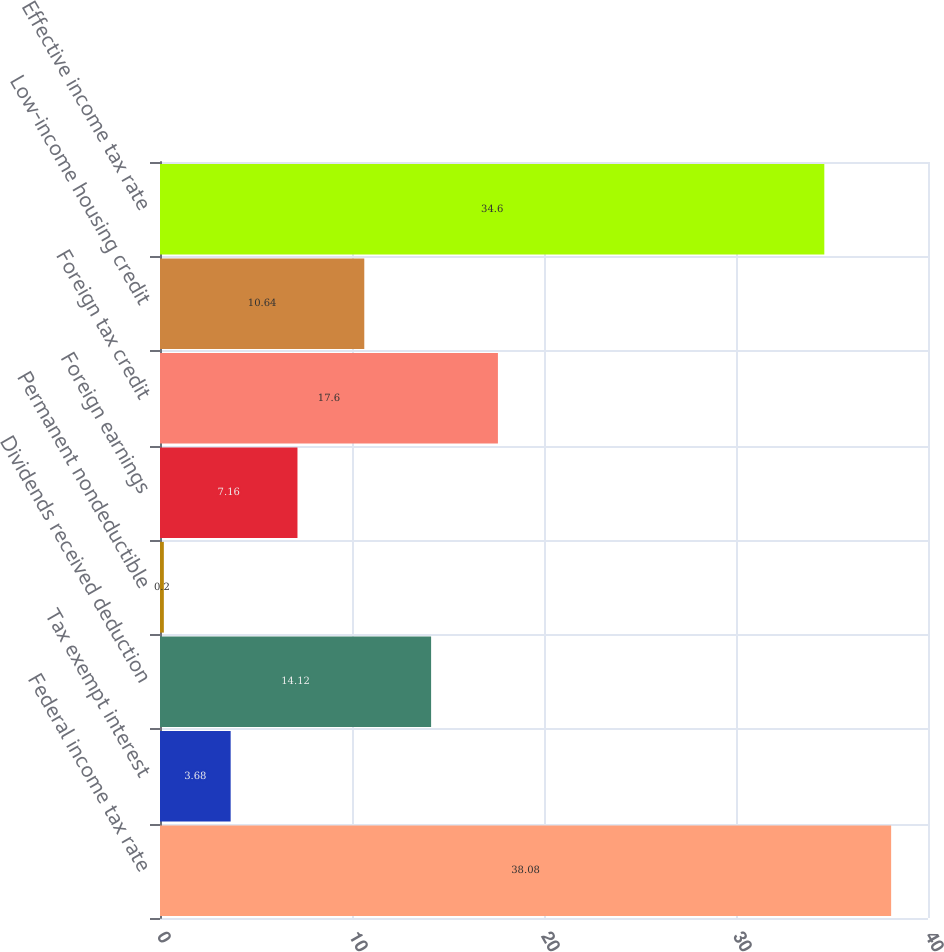Convert chart. <chart><loc_0><loc_0><loc_500><loc_500><bar_chart><fcel>Federal income tax rate<fcel>Tax exempt interest<fcel>Dividends received deduction<fcel>Permanent nondeductible<fcel>Foreign earnings<fcel>Foreign tax credit<fcel>Low-income housing credit<fcel>Effective income tax rate<nl><fcel>38.08<fcel>3.68<fcel>14.12<fcel>0.2<fcel>7.16<fcel>17.6<fcel>10.64<fcel>34.6<nl></chart> 